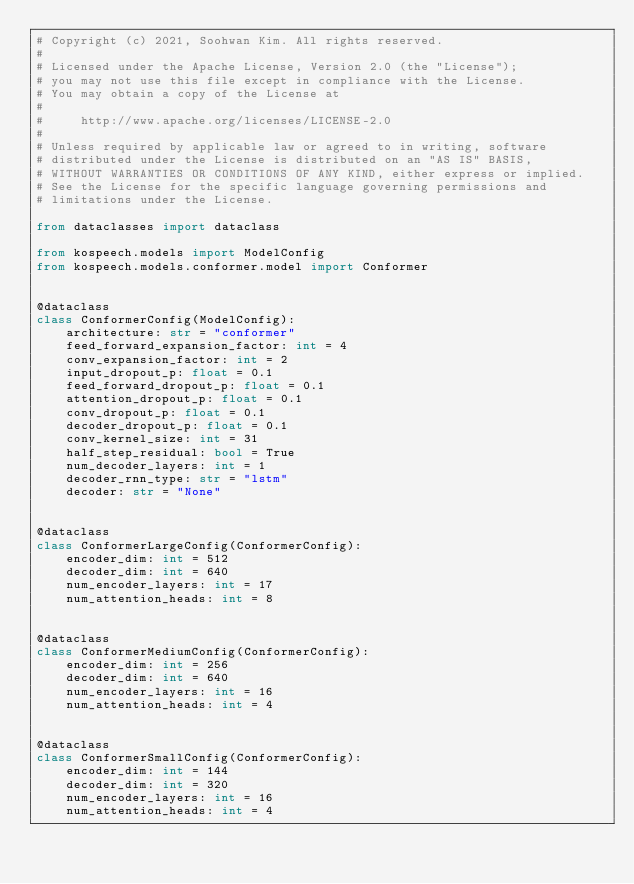Convert code to text. <code><loc_0><loc_0><loc_500><loc_500><_Python_># Copyright (c) 2021, Soohwan Kim. All rights reserved.
#
# Licensed under the Apache License, Version 2.0 (the "License");
# you may not use this file except in compliance with the License.
# You may obtain a copy of the License at
#
#     http://www.apache.org/licenses/LICENSE-2.0
#
# Unless required by applicable law or agreed to in writing, software
# distributed under the License is distributed on an "AS IS" BASIS,
# WITHOUT WARRANTIES OR CONDITIONS OF ANY KIND, either express or implied.
# See the License for the specific language governing permissions and
# limitations under the License.

from dataclasses import dataclass

from kospeech.models import ModelConfig
from kospeech.models.conformer.model import Conformer


@dataclass
class ConformerConfig(ModelConfig):
    architecture: str = "conformer"
    feed_forward_expansion_factor: int = 4
    conv_expansion_factor: int = 2
    input_dropout_p: float = 0.1
    feed_forward_dropout_p: float = 0.1
    attention_dropout_p: float = 0.1
    conv_dropout_p: float = 0.1
    decoder_dropout_p: float = 0.1
    conv_kernel_size: int = 31
    half_step_residual: bool = True
    num_decoder_layers: int = 1
    decoder_rnn_type: str = "lstm"
    decoder: str = "None"


@dataclass
class ConformerLargeConfig(ConformerConfig):
    encoder_dim: int = 512
    decoder_dim: int = 640
    num_encoder_layers: int = 17
    num_attention_heads: int = 8


@dataclass
class ConformerMediumConfig(ConformerConfig):
    encoder_dim: int = 256
    decoder_dim: int = 640
    num_encoder_layers: int = 16
    num_attention_heads: int = 4


@dataclass
class ConformerSmallConfig(ConformerConfig):
    encoder_dim: int = 144
    decoder_dim: int = 320
    num_encoder_layers: int = 16
    num_attention_heads: int = 4
</code> 